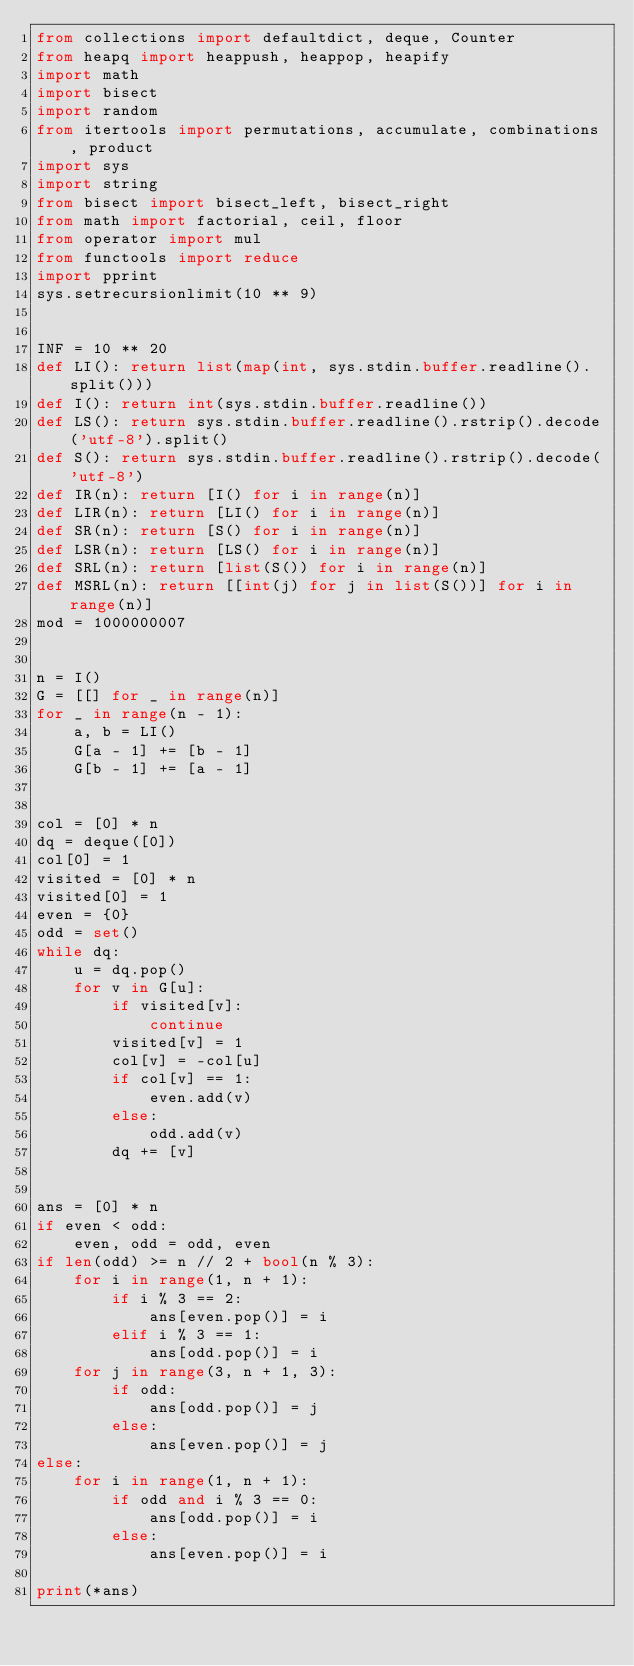<code> <loc_0><loc_0><loc_500><loc_500><_Python_>from collections import defaultdict, deque, Counter
from heapq import heappush, heappop, heapify
import math
import bisect
import random
from itertools import permutations, accumulate, combinations, product
import sys
import string
from bisect import bisect_left, bisect_right
from math import factorial, ceil, floor
from operator import mul
from functools import reduce
import pprint
sys.setrecursionlimit(10 ** 9)


INF = 10 ** 20
def LI(): return list(map(int, sys.stdin.buffer.readline().split()))
def I(): return int(sys.stdin.buffer.readline())
def LS(): return sys.stdin.buffer.readline().rstrip().decode('utf-8').split()
def S(): return sys.stdin.buffer.readline().rstrip().decode('utf-8')
def IR(n): return [I() for i in range(n)]
def LIR(n): return [LI() for i in range(n)]
def SR(n): return [S() for i in range(n)]
def LSR(n): return [LS() for i in range(n)]
def SRL(n): return [list(S()) for i in range(n)]
def MSRL(n): return [[int(j) for j in list(S())] for i in range(n)]
mod = 1000000007


n = I()
G = [[] for _ in range(n)]
for _ in range(n - 1):
    a, b = LI()
    G[a - 1] += [b - 1]
    G[b - 1] += [a - 1]


col = [0] * n
dq = deque([0])
col[0] = 1
visited = [0] * n
visited[0] = 1
even = {0}
odd = set()
while dq:
    u = dq.pop()
    for v in G[u]:
        if visited[v]:
            continue
        visited[v] = 1
        col[v] = -col[u]
        if col[v] == 1:
            even.add(v)
        else:
            odd.add(v)
        dq += [v]


ans = [0] * n
if even < odd:
    even, odd = odd, even
if len(odd) >= n // 2 + bool(n % 3):
    for i in range(1, n + 1):
        if i % 3 == 2:
            ans[even.pop()] = i
        elif i % 3 == 1:
            ans[odd.pop()] = i
    for j in range(3, n + 1, 3):
        if odd:
            ans[odd.pop()] = j
        else:
            ans[even.pop()] = j
else:
    for i in range(1, n + 1):
        if odd and i % 3 == 0:
            ans[odd.pop()] = i
        else:
            ans[even.pop()] = i

print(*ans)









</code> 